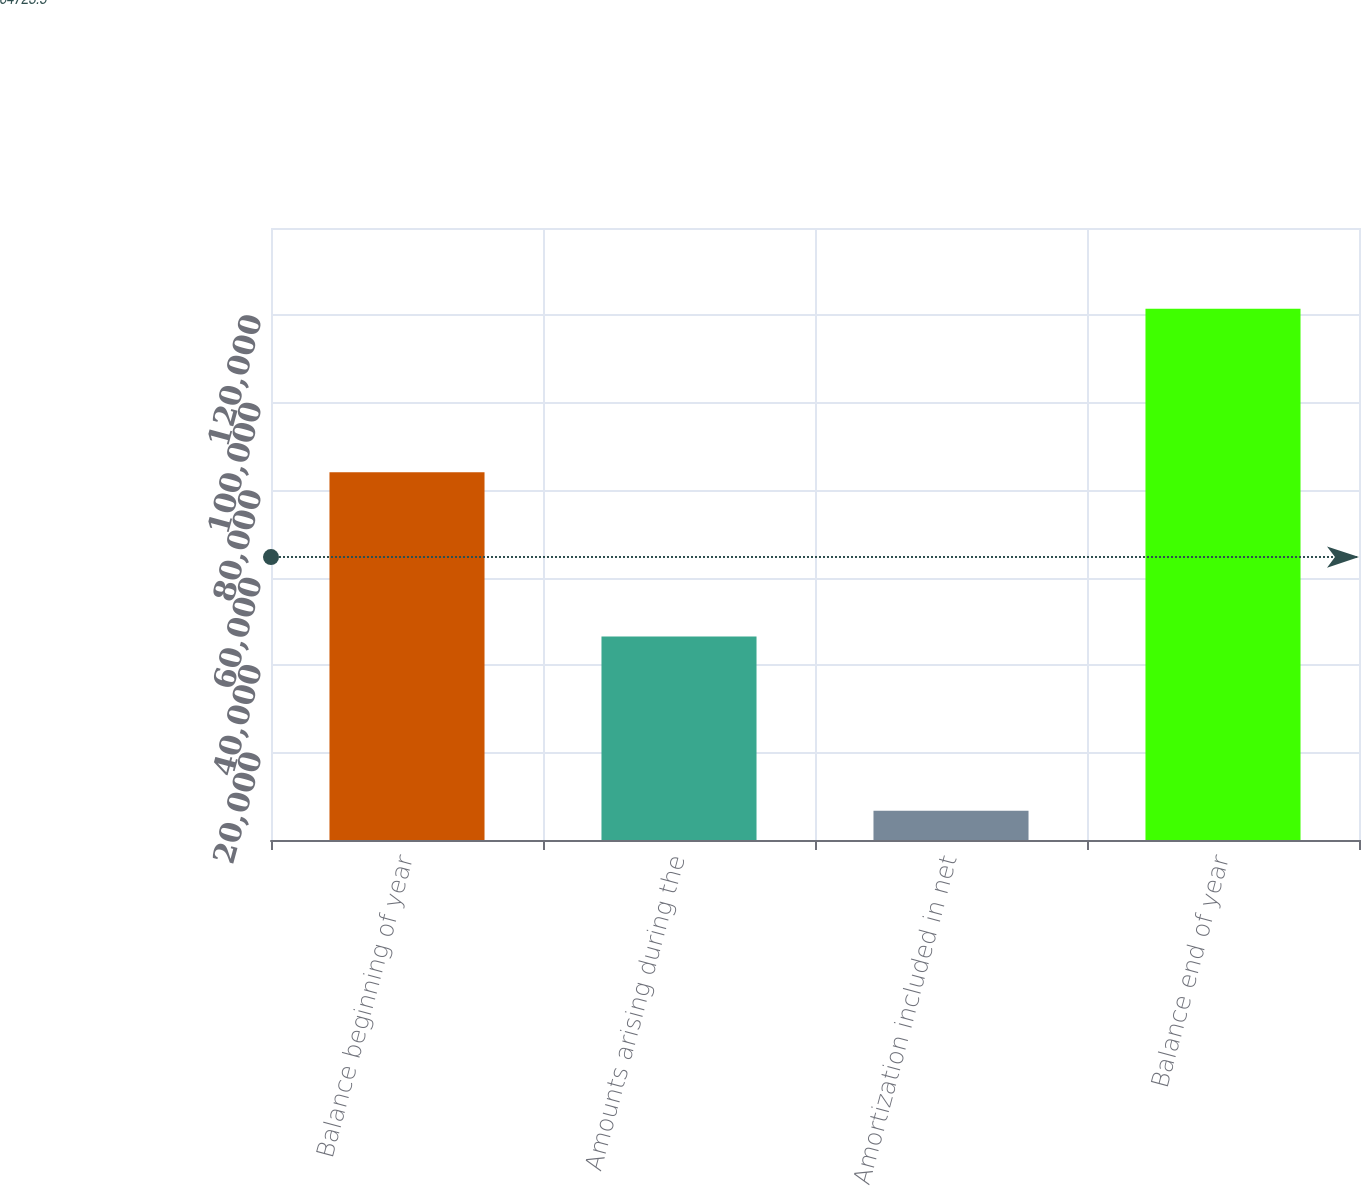Convert chart to OTSL. <chart><loc_0><loc_0><loc_500><loc_500><bar_chart><fcel>Balance beginning of year<fcel>Amounts arising during the<fcel>Amortization included in net<fcel>Balance end of year<nl><fcel>84122<fcel>46580<fcel>6670<fcel>121522<nl></chart> 